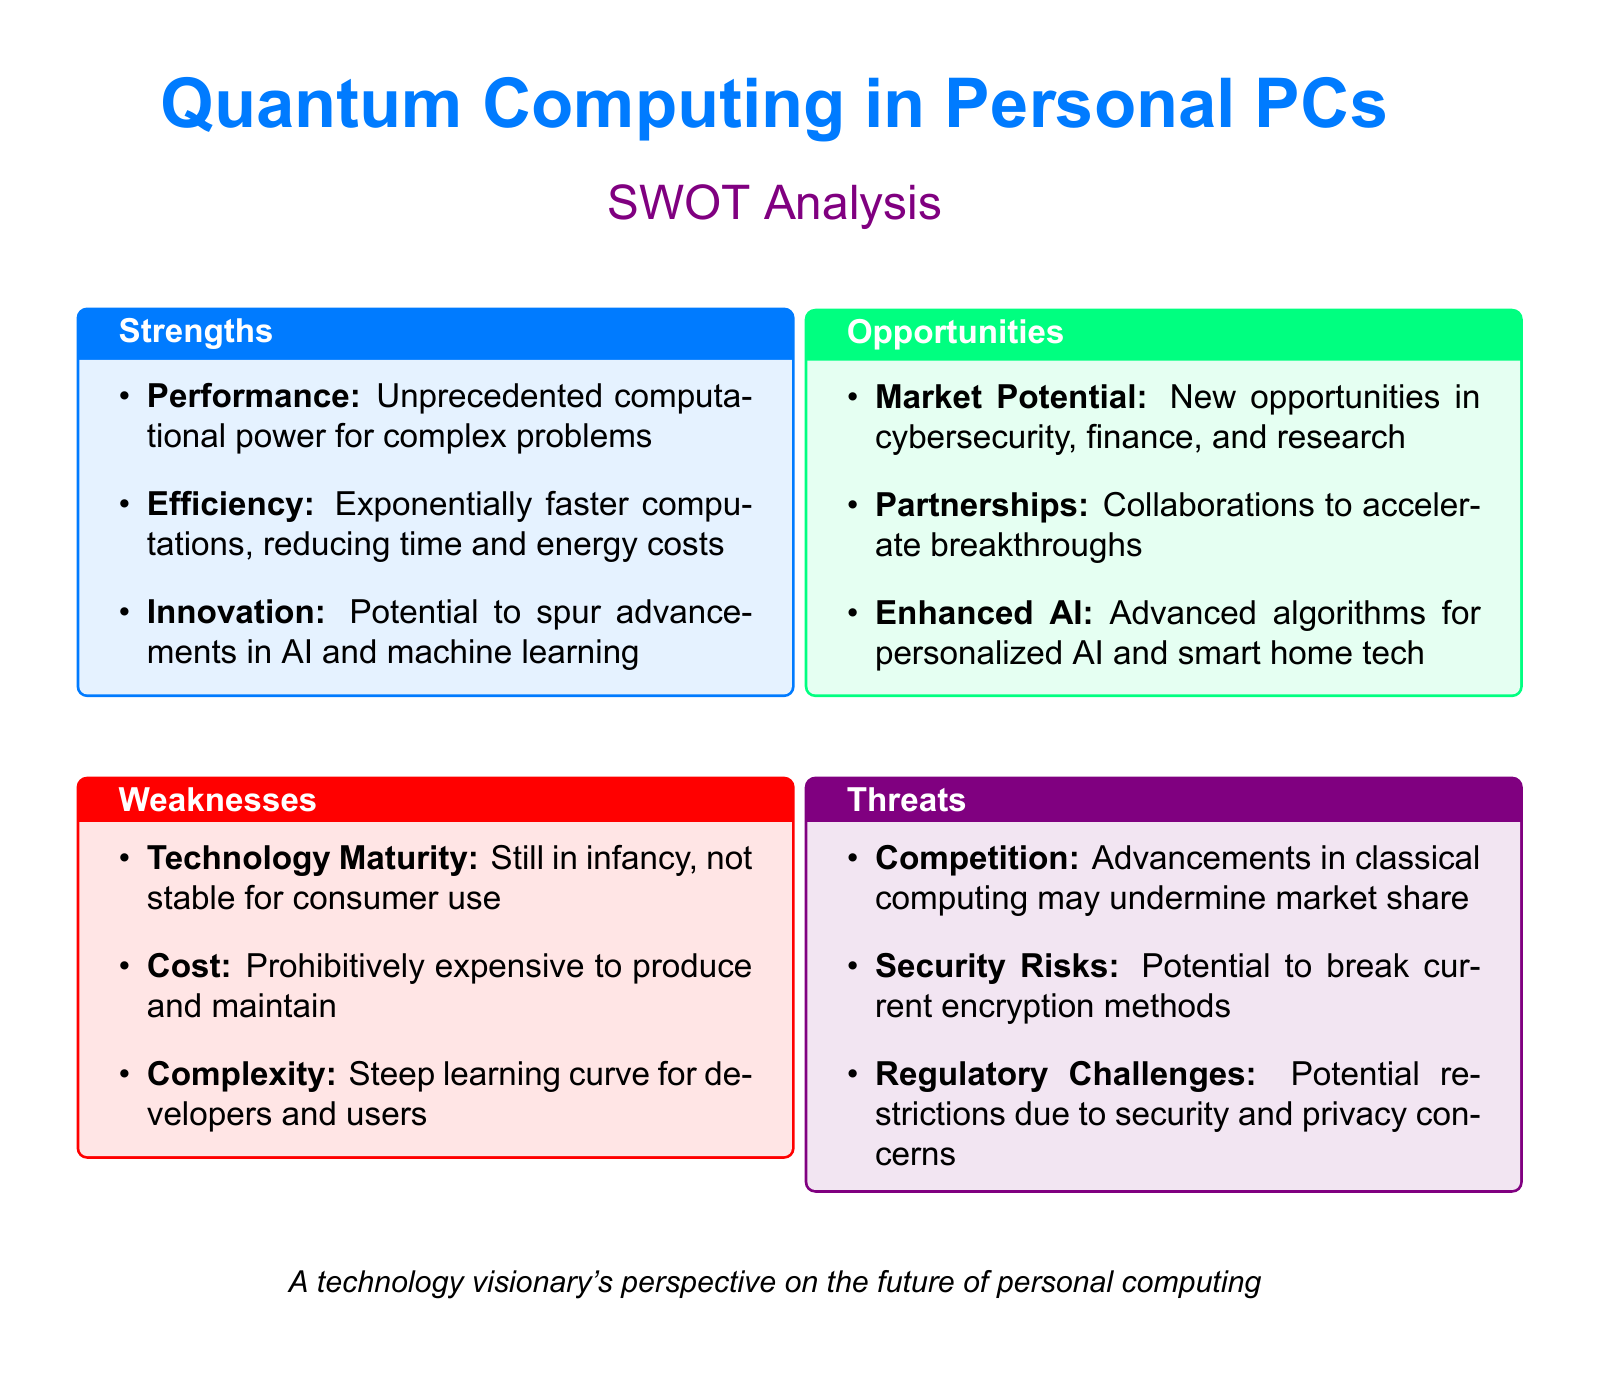What are the strengths of quantum computing? The strengths are listed in the document, highlighting aspects like performance, efficiency, and innovation.
Answer: Performance, Efficiency, Innovation What is a weakness related to the maturity of quantum computing? The document mentions that technology maturity is still in its infancy and not stable for consumer use.
Answer: Technology Maturity What market potential is associated with quantum computing? Market potential opportunities include new advancements in fields like cybersecurity, finance, and research, as stated in the document.
Answer: Cybersecurity, finance, and research What is one of the threats posed by quantum computing? The document outlines various threats, including competition from classical computing and regulatory challenges.
Answer: Competition How many strengths are listed in the SWOT analysis? The document enumerates three strengths under the strengths section.
Answer: Three What does the weakness section mention about cost? The document clearly states that one of the weaknesses is the prohibitively expensive nature of quantum computing.
Answer: Prohibitively expensive What opportunities does quantum computing present for AI? The document points to advanced algorithms for enhanced AI and smart home technology as key opportunities.
Answer: Enhanced AI What color theme is used for the threats section? Each section of the document is color-coded, with the threats section highlighted in quantumpurple.
Answer: Quantumpurple 